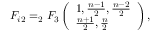<formula> <loc_0><loc_0><loc_500><loc_500>F _ { i 2 } = _ { 2 } F _ { 3 } \left ( \begin{array} { l } { { 1 , \frac { n - 1 } { 2 } , \frac { n - 2 } { 2 } } } \\ { { \frac { n + 1 } { 2 } , \frac { n } { 2 } } } \end{array} \right ) ,</formula> 